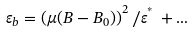Convert formula to latex. <formula><loc_0><loc_0><loc_500><loc_500>\varepsilon _ { b } = \left ( \mu ( B - B _ { 0 } ) \right ) ^ { 2 } / \varepsilon ^ { ^ { * } } \, + \dots</formula> 